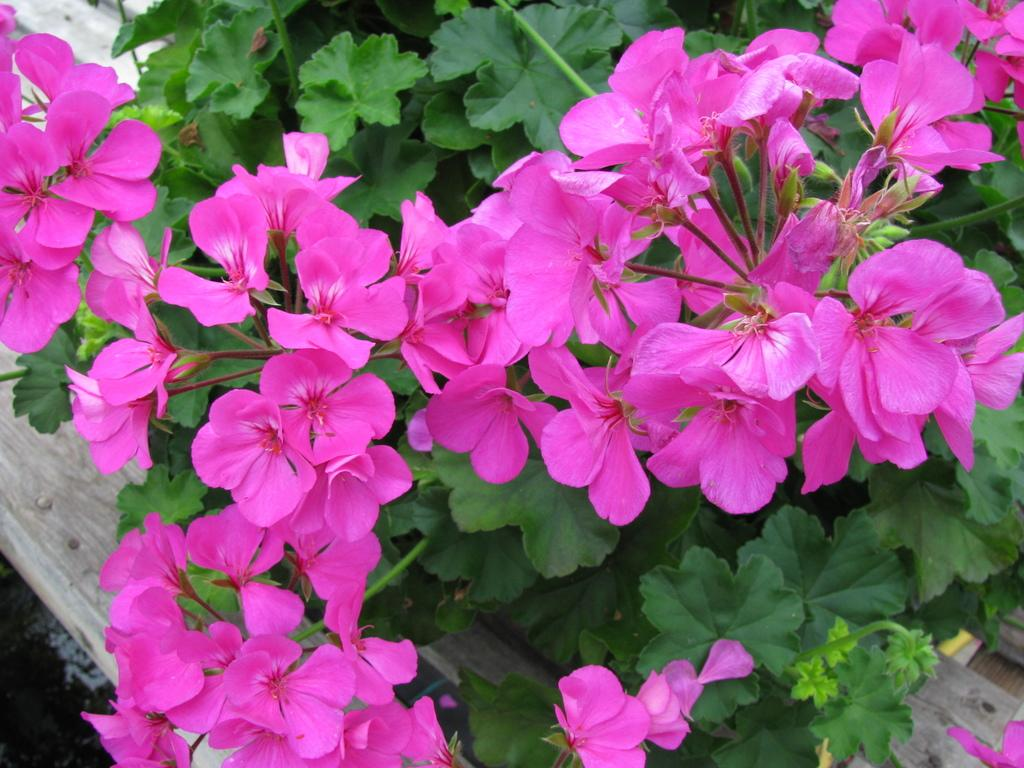What type of living organisms can be seen in the image? Plants and flowers are visible in the image. What color are the flowers in the image? The flowers in the image are pink in color. What material is the wooden plank made of? The wooden plank in the image is made of wood. What type of kite can be seen flying in the image? There is no kite present in the image; it features plants, flowers, and a wooden plank. What brand of soda is being advertised on the wooden plank in the image? There is no soda or advertisement present on the wooden plank in the image. 